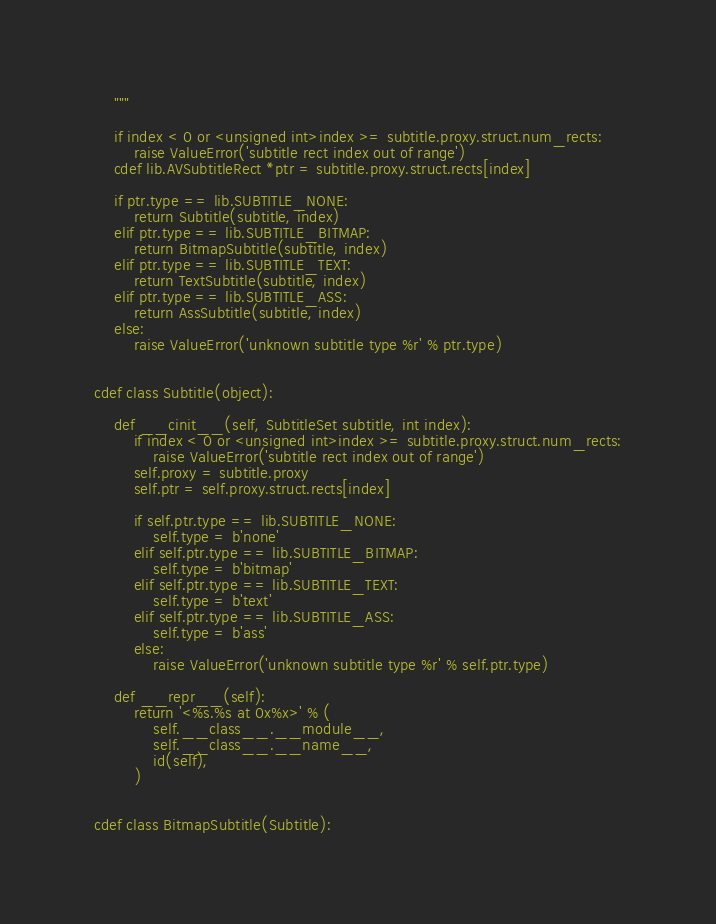Convert code to text. <code><loc_0><loc_0><loc_500><loc_500><_Cython_>    """

    if index < 0 or <unsigned int>index >= subtitle.proxy.struct.num_rects:
        raise ValueError('subtitle rect index out of range')
    cdef lib.AVSubtitleRect *ptr = subtitle.proxy.struct.rects[index]

    if ptr.type == lib.SUBTITLE_NONE:
        return Subtitle(subtitle, index)
    elif ptr.type == lib.SUBTITLE_BITMAP:
        return BitmapSubtitle(subtitle, index)
    elif ptr.type == lib.SUBTITLE_TEXT:
        return TextSubtitle(subtitle, index)
    elif ptr.type == lib.SUBTITLE_ASS:
        return AssSubtitle(subtitle, index)
    else:
        raise ValueError('unknown subtitle type %r' % ptr.type)


cdef class Subtitle(object):

    def __cinit__(self, SubtitleSet subtitle, int index):
        if index < 0 or <unsigned int>index >= subtitle.proxy.struct.num_rects:
            raise ValueError('subtitle rect index out of range')
        self.proxy = subtitle.proxy
        self.ptr = self.proxy.struct.rects[index]

        if self.ptr.type == lib.SUBTITLE_NONE:
            self.type = b'none'
        elif self.ptr.type == lib.SUBTITLE_BITMAP:
            self.type = b'bitmap'
        elif self.ptr.type == lib.SUBTITLE_TEXT:
            self.type = b'text'
        elif self.ptr.type == lib.SUBTITLE_ASS:
            self.type = b'ass'
        else:
            raise ValueError('unknown subtitle type %r' % self.ptr.type)

    def __repr__(self):
        return '<%s.%s at 0x%x>' % (
            self.__class__.__module__,
            self.__class__.__name__,
            id(self),
        )


cdef class BitmapSubtitle(Subtitle):
</code> 